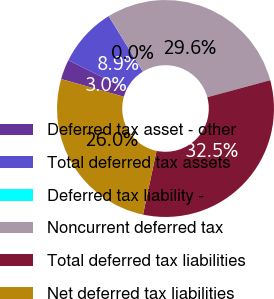<chart> <loc_0><loc_0><loc_500><loc_500><pie_chart><fcel>Deferred tax asset - other<fcel>Total deferred tax assets<fcel>Deferred tax liability -<fcel>Noncurrent deferred tax<fcel>Total deferred tax liabilities<fcel>Net deferred tax liabilities<nl><fcel>2.97%<fcel>8.88%<fcel>0.01%<fcel>29.57%<fcel>32.53%<fcel>26.05%<nl></chart> 